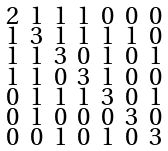Convert formula to latex. <formula><loc_0><loc_0><loc_500><loc_500>\begin{smallmatrix} 2 & 1 & 1 & 1 & 0 & 0 & 0 \\ 1 & 3 & 1 & 1 & 1 & 1 & 0 \\ 1 & 1 & 3 & 0 & 1 & 0 & 1 \\ 1 & 1 & 0 & 3 & 1 & 0 & 0 \\ 0 & 1 & 1 & 1 & 3 & 0 & 1 \\ 0 & 1 & 0 & 0 & 0 & 3 & 0 \\ 0 & 0 & 1 & 0 & 1 & 0 & 3 \end{smallmatrix}</formula> 